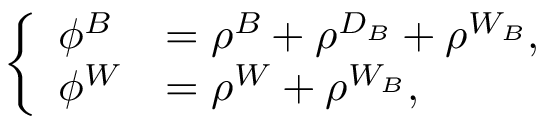<formula> <loc_0><loc_0><loc_500><loc_500>\left \{ \begin{array} { l l } { \phi ^ { B } } & { = \rho ^ { B } + \rho ^ { D _ { B } } + \rho ^ { W _ { B } } , } \\ { \phi ^ { W } } & { = \rho ^ { W } + \rho ^ { W _ { B } } , } \end{array}</formula> 